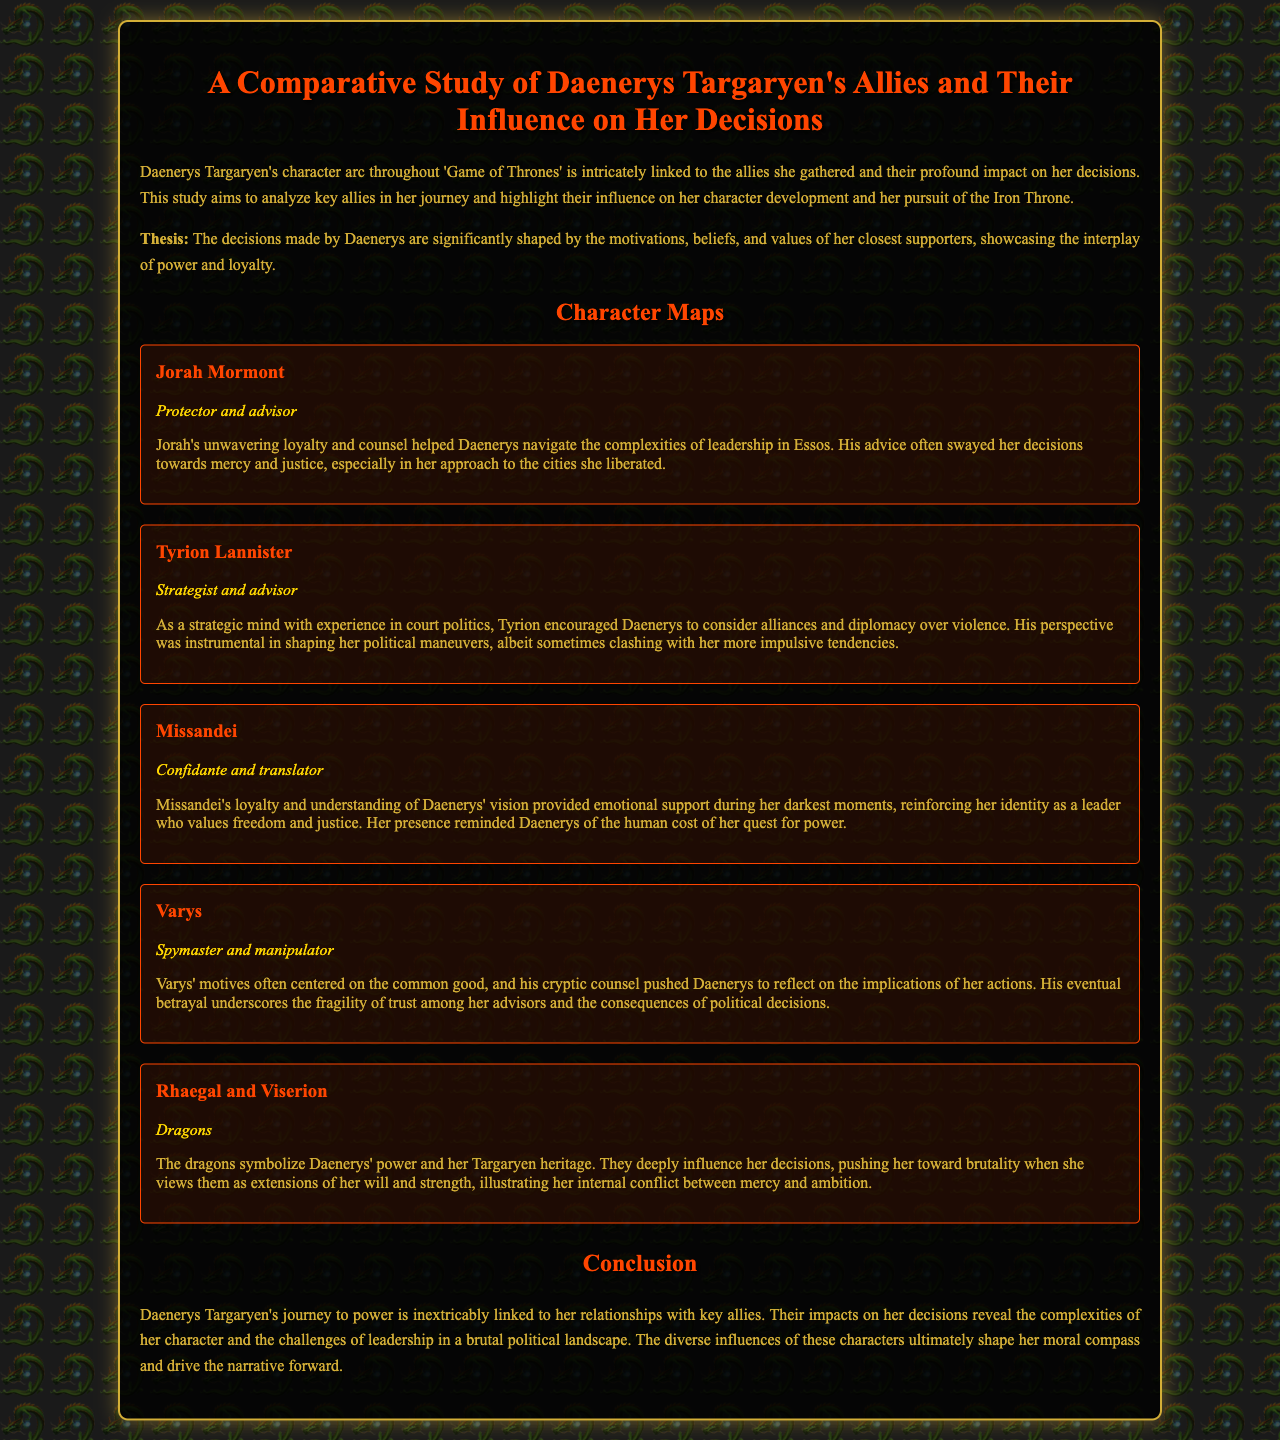What is the title of the report? The title of the report is stated in the header section, summarizing the focus of the study.
Answer: A Comparative Study of Daenerys Targaryen's Allies and Their Influence on Her Decisions Who is described as the "Protector and advisor"? This role is explicitly assigned to Jorah Mormont in the character map section of the document.
Answer: Jorah Mormont What advice did Tyrion Lannister provide to Daenerys? The document notes that Tyrion encouraged Daenerys to consider alliances and diplomacy over violence.
Answer: Alliances and diplomacy Which character is identified as Daenerys' "Confidante and translator"? The document provides a direct label for Missandei's role in relation to Daenerys.
Answer: Missandei How do the dragons influence Daenerys' decisions? The influence mentioned in the document indicates that they push her towards brutality when viewed as extensions of her will and strength.
Answer: Brutality What is the main theme of the report's conclusion? The conclusion addresses the comprehensive influence of Daenerys' allies on her journey to power, revealing complexities in her character.
Answer: Relationships with key allies Which character's loyalty provides emotional support during Daenerys' darkest moments? The character identified for this role is highlighted as crucial for emotional guidance in the document.
Answer: Missandei What motivates Varys' actions as per the document? The document discusses his focus on the common good as the basis for his motives.
Answer: Common good 